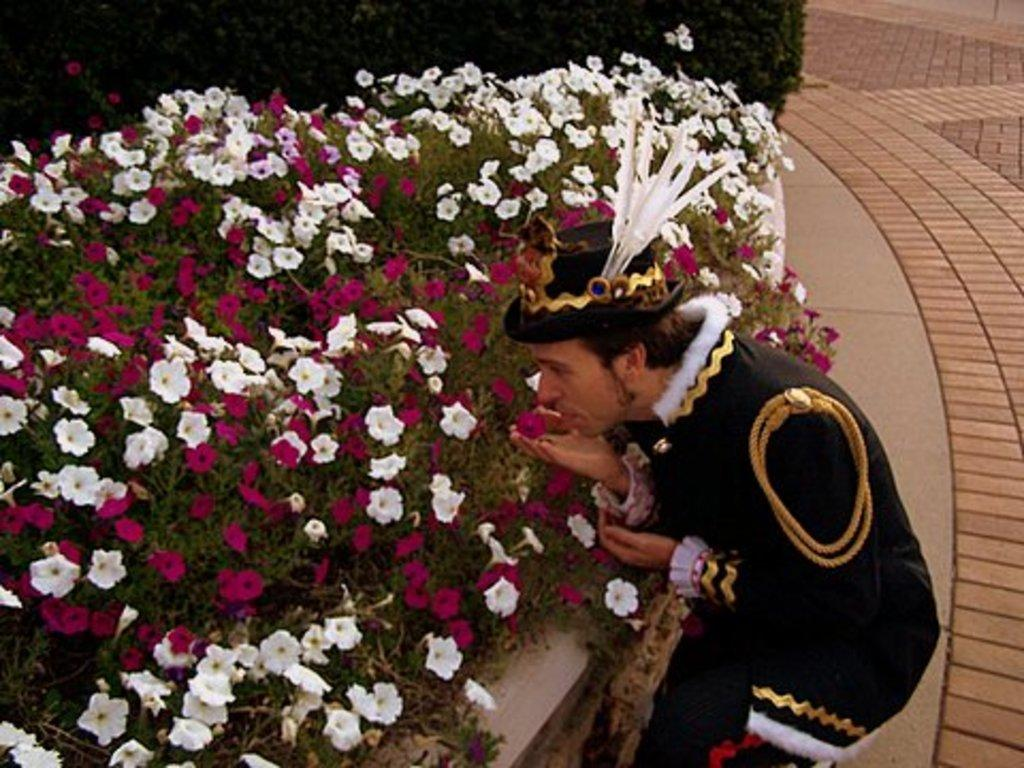What type of plants are on the left side of the image? There are flower plants on the left side of the image. What is the man in the image doing? The man is smelling a flower in the image. What can be seen on the right side of the image? There is a path on the right side of the image. How many ducks are swimming in the flower plants on the left side of the image? There are no ducks present in the image; it features flower plants and a man smelling a flower. What is the relation between the man and the flower plants in the image? The provided facts do not mention any relation between the man and the flower plants; the man is simply smelling a flower. 